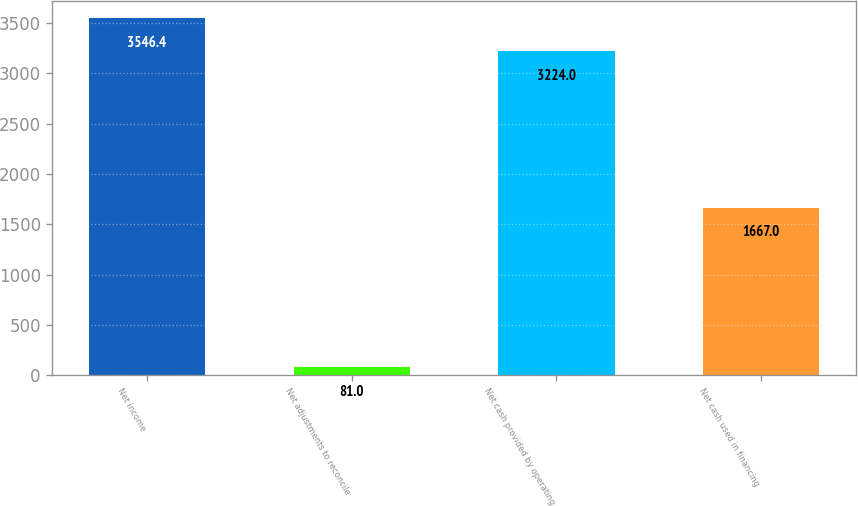Convert chart to OTSL. <chart><loc_0><loc_0><loc_500><loc_500><bar_chart><fcel>Net income<fcel>Net adjustments to reconcile<fcel>Net cash provided by operating<fcel>Net cash used in financing<nl><fcel>3546.4<fcel>81<fcel>3224<fcel>1667<nl></chart> 